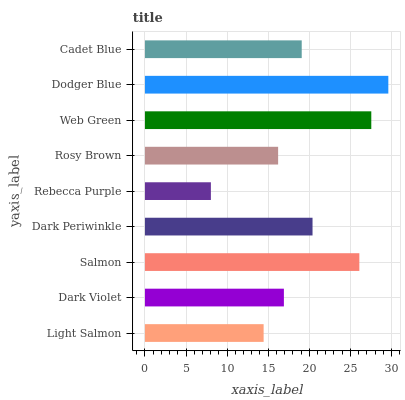Is Rebecca Purple the minimum?
Answer yes or no. Yes. Is Dodger Blue the maximum?
Answer yes or no. Yes. Is Dark Violet the minimum?
Answer yes or no. No. Is Dark Violet the maximum?
Answer yes or no. No. Is Dark Violet greater than Light Salmon?
Answer yes or no. Yes. Is Light Salmon less than Dark Violet?
Answer yes or no. Yes. Is Light Salmon greater than Dark Violet?
Answer yes or no. No. Is Dark Violet less than Light Salmon?
Answer yes or no. No. Is Cadet Blue the high median?
Answer yes or no. Yes. Is Cadet Blue the low median?
Answer yes or no. Yes. Is Dodger Blue the high median?
Answer yes or no. No. Is Rosy Brown the low median?
Answer yes or no. No. 